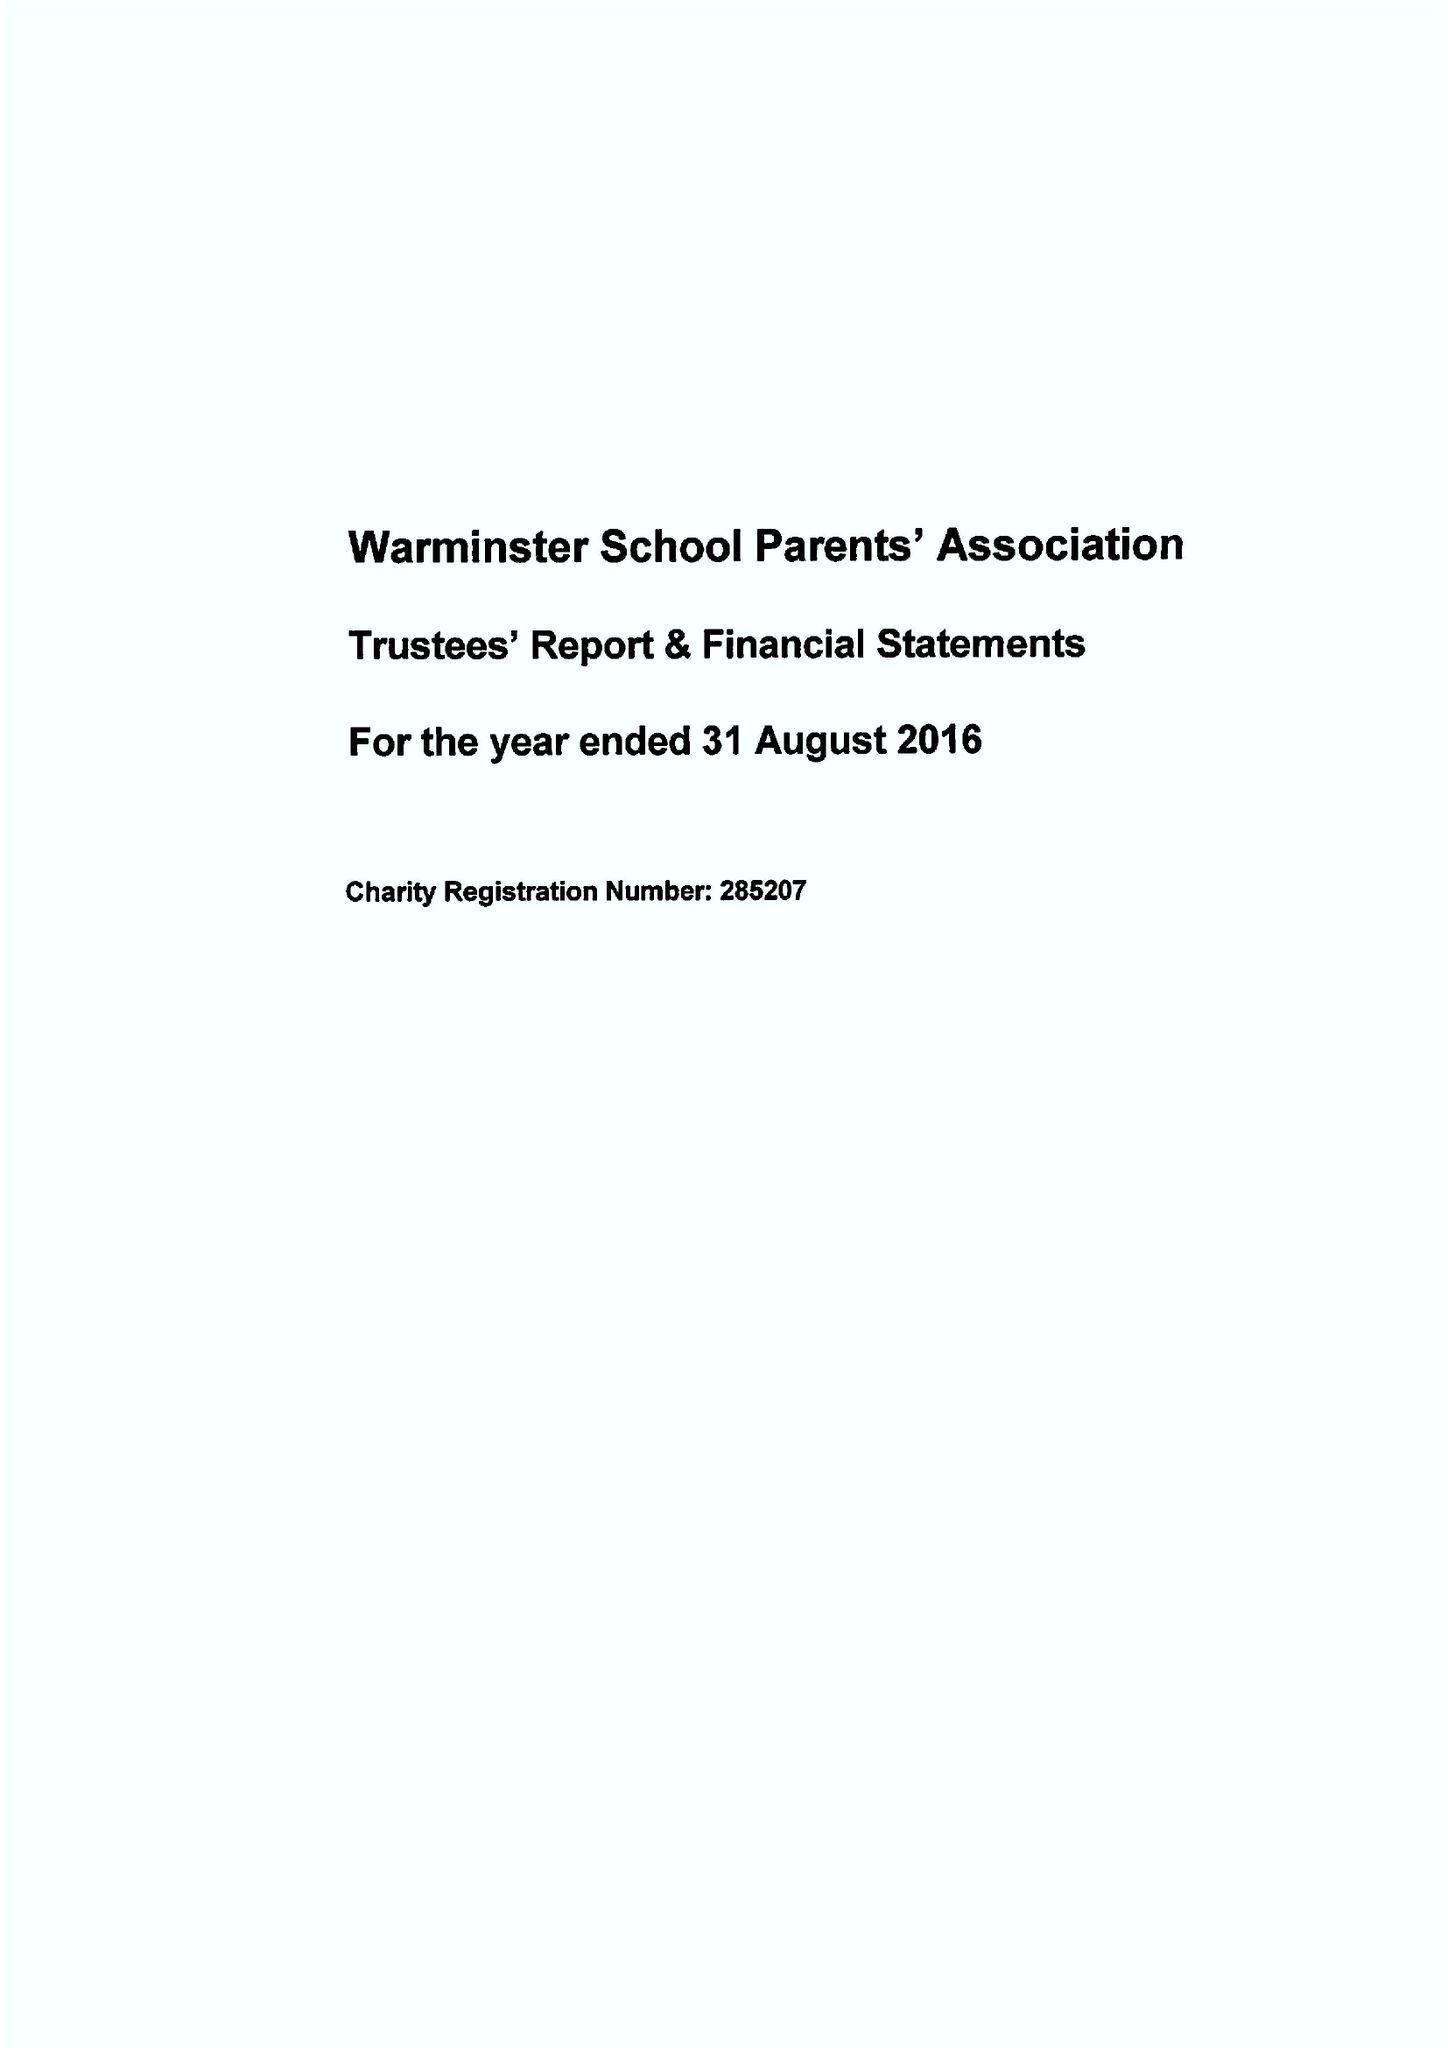What is the value for the spending_annually_in_british_pounds?
Answer the question using a single word or phrase. 36772.00 